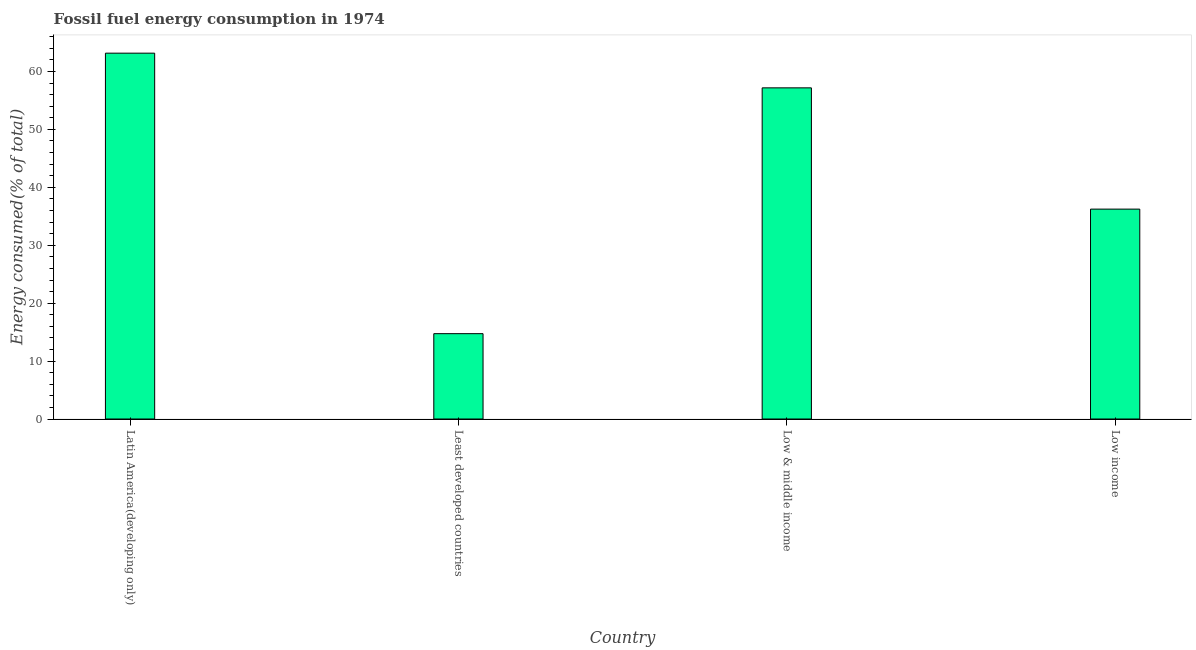Does the graph contain any zero values?
Offer a very short reply. No. What is the title of the graph?
Provide a short and direct response. Fossil fuel energy consumption in 1974. What is the label or title of the Y-axis?
Offer a terse response. Energy consumed(% of total). What is the fossil fuel energy consumption in Least developed countries?
Offer a terse response. 14.74. Across all countries, what is the maximum fossil fuel energy consumption?
Your response must be concise. 63.16. Across all countries, what is the minimum fossil fuel energy consumption?
Provide a succinct answer. 14.74. In which country was the fossil fuel energy consumption maximum?
Ensure brevity in your answer.  Latin America(developing only). In which country was the fossil fuel energy consumption minimum?
Offer a very short reply. Least developed countries. What is the sum of the fossil fuel energy consumption?
Keep it short and to the point. 171.31. What is the difference between the fossil fuel energy consumption in Least developed countries and Low & middle income?
Your response must be concise. -42.44. What is the average fossil fuel energy consumption per country?
Your answer should be very brief. 42.83. What is the median fossil fuel energy consumption?
Give a very brief answer. 46.71. What is the ratio of the fossil fuel energy consumption in Least developed countries to that in Low income?
Ensure brevity in your answer.  0.41. Is the fossil fuel energy consumption in Latin America(developing only) less than that in Least developed countries?
Make the answer very short. No. What is the difference between the highest and the second highest fossil fuel energy consumption?
Provide a short and direct response. 5.99. What is the difference between the highest and the lowest fossil fuel energy consumption?
Give a very brief answer. 48.43. Are all the bars in the graph horizontal?
Keep it short and to the point. No. What is the difference between two consecutive major ticks on the Y-axis?
Provide a succinct answer. 10. What is the Energy consumed(% of total) in Latin America(developing only)?
Make the answer very short. 63.16. What is the Energy consumed(% of total) of Least developed countries?
Your response must be concise. 14.74. What is the Energy consumed(% of total) of Low & middle income?
Give a very brief answer. 57.17. What is the Energy consumed(% of total) in Low income?
Offer a very short reply. 36.24. What is the difference between the Energy consumed(% of total) in Latin America(developing only) and Least developed countries?
Keep it short and to the point. 48.43. What is the difference between the Energy consumed(% of total) in Latin America(developing only) and Low & middle income?
Offer a very short reply. 5.99. What is the difference between the Energy consumed(% of total) in Latin America(developing only) and Low income?
Provide a short and direct response. 26.92. What is the difference between the Energy consumed(% of total) in Least developed countries and Low & middle income?
Your response must be concise. -42.44. What is the difference between the Energy consumed(% of total) in Least developed countries and Low income?
Your answer should be very brief. -21.5. What is the difference between the Energy consumed(% of total) in Low & middle income and Low income?
Your answer should be compact. 20.93. What is the ratio of the Energy consumed(% of total) in Latin America(developing only) to that in Least developed countries?
Provide a succinct answer. 4.29. What is the ratio of the Energy consumed(% of total) in Latin America(developing only) to that in Low & middle income?
Give a very brief answer. 1.1. What is the ratio of the Energy consumed(% of total) in Latin America(developing only) to that in Low income?
Make the answer very short. 1.74. What is the ratio of the Energy consumed(% of total) in Least developed countries to that in Low & middle income?
Provide a succinct answer. 0.26. What is the ratio of the Energy consumed(% of total) in Least developed countries to that in Low income?
Your answer should be very brief. 0.41. What is the ratio of the Energy consumed(% of total) in Low & middle income to that in Low income?
Your response must be concise. 1.58. 